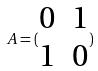<formula> <loc_0><loc_0><loc_500><loc_500>A = ( \begin{matrix} 0 & 1 \\ 1 & 0 \end{matrix} )</formula> 